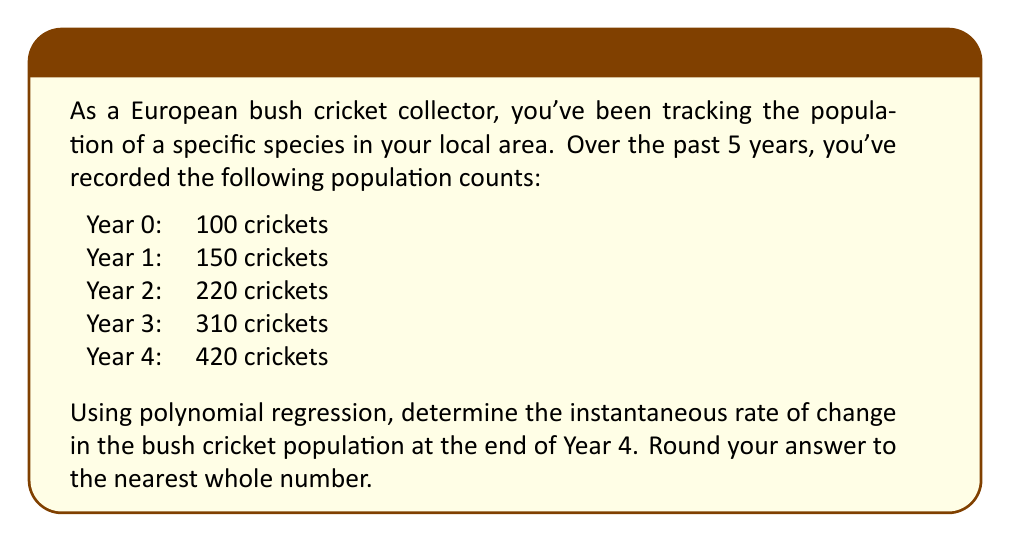Show me your answer to this math problem. To solve this problem, we'll follow these steps:

1) First, we need to find a polynomial function that fits the given data points. Let's use a quadratic function of the form $f(x) = ax^2 + bx + c$, where $x$ represents the year and $f(x)$ represents the population.

2) We can use a system of equations to find the values of $a$, $b$, and $c$:

   $$100 = a(0)^2 + b(0) + c$$
   $$150 = a(1)^2 + b(1) + c$$
   $$220 = a(2)^2 + b(2) + c$$
   $$310 = a(3)^2 + b(3) + c$$
   $$420 = a(4)^2 + b(4) + c$$

3) Solving this system (using a computer algebra system or calculator), we get:
   
   $a = 10$, $b = 30$, $c = 100$

4) So our polynomial function is:

   $$f(x) = 10x^2 + 30x + 100$$

5) To find the instantaneous rate of change at Year 4, we need to find the derivative of this function and evaluate it at $x = 4$:

   $$f'(x) = 20x + 30$$

6) Evaluating at $x = 4$:

   $$f'(4) = 20(4) + 30 = 110$$

7) Rounding to the nearest whole number, we get 110.
Answer: 110 crickets per year 